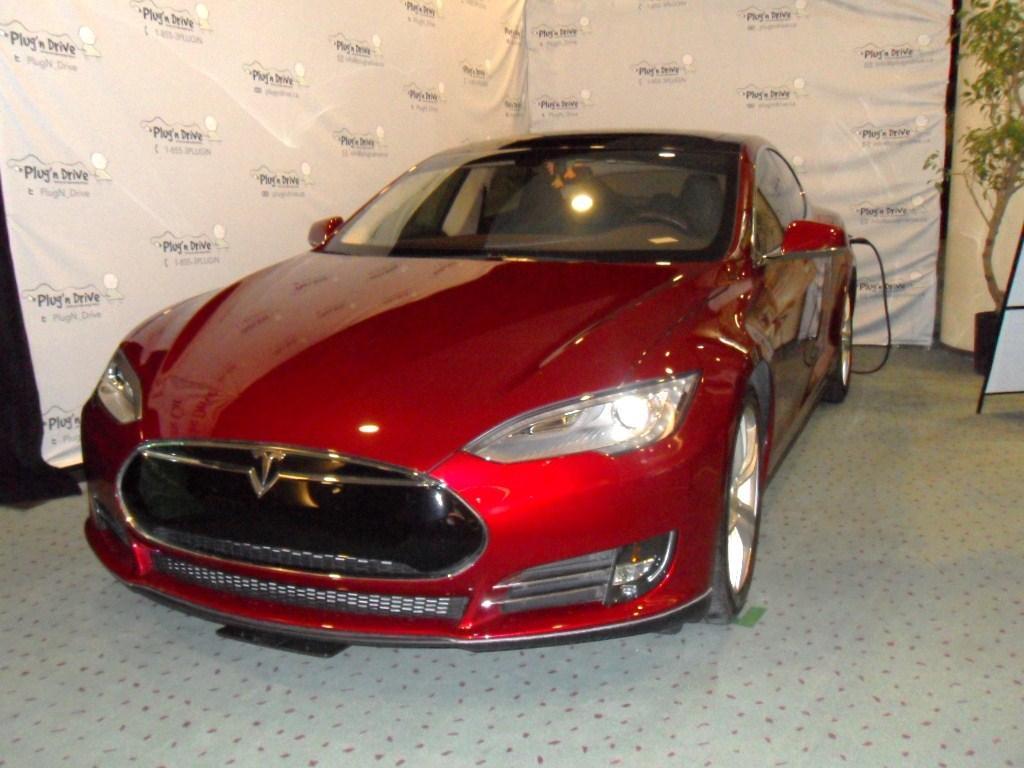Describe this image in one or two sentences. In this image, I can see a car on the floor. In the background, I can see the banners. On the right side of the image, there is a board, a pillar and a plant in a flower pot. 